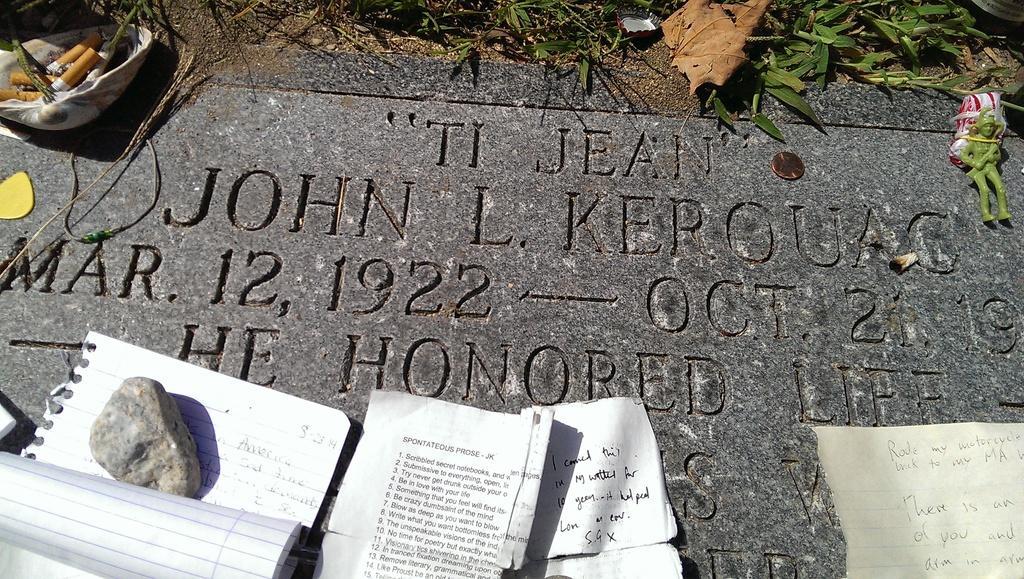Describe this image in one or two sentences. In this image there is a doll at right side of this image and there is a small grass at top of this image and there are some papers are kept at bottom of this image, and there is a stone at left side of this image,and there are some objects are kept at top left corner of this image. There is a board on which the text is written is at middle of this image. 